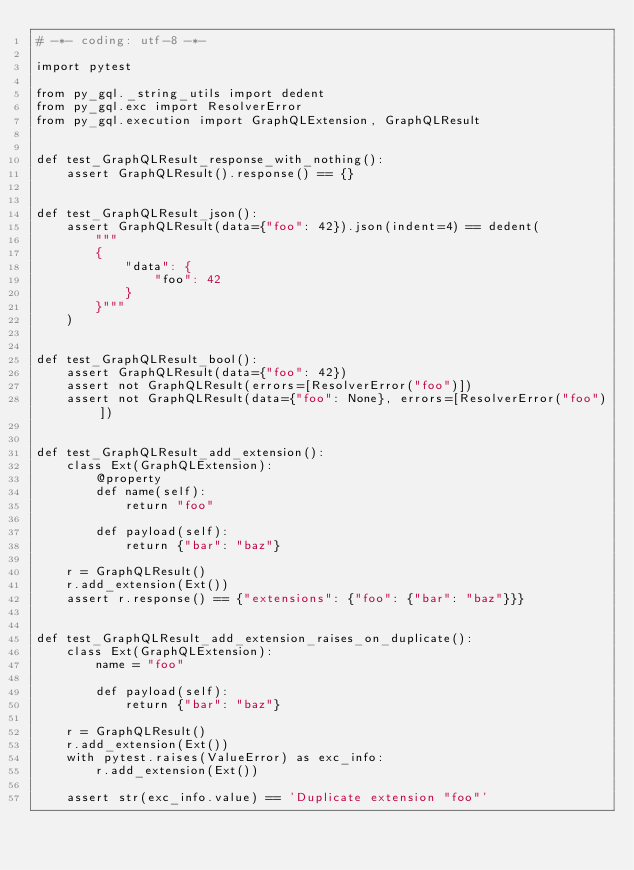Convert code to text. <code><loc_0><loc_0><loc_500><loc_500><_Python_># -*- coding: utf-8 -*-

import pytest

from py_gql._string_utils import dedent
from py_gql.exc import ResolverError
from py_gql.execution import GraphQLExtension, GraphQLResult


def test_GraphQLResult_response_with_nothing():
    assert GraphQLResult().response() == {}


def test_GraphQLResult_json():
    assert GraphQLResult(data={"foo": 42}).json(indent=4) == dedent(
        """
        {
            "data": {
                "foo": 42
            }
        }"""
    )


def test_GraphQLResult_bool():
    assert GraphQLResult(data={"foo": 42})
    assert not GraphQLResult(errors=[ResolverError("foo")])
    assert not GraphQLResult(data={"foo": None}, errors=[ResolverError("foo")])


def test_GraphQLResult_add_extension():
    class Ext(GraphQLExtension):
        @property
        def name(self):
            return "foo"

        def payload(self):
            return {"bar": "baz"}

    r = GraphQLResult()
    r.add_extension(Ext())
    assert r.response() == {"extensions": {"foo": {"bar": "baz"}}}


def test_GraphQLResult_add_extension_raises_on_duplicate():
    class Ext(GraphQLExtension):
        name = "foo"

        def payload(self):
            return {"bar": "baz"}

    r = GraphQLResult()
    r.add_extension(Ext())
    with pytest.raises(ValueError) as exc_info:
        r.add_extension(Ext())

    assert str(exc_info.value) == 'Duplicate extension "foo"'
</code> 